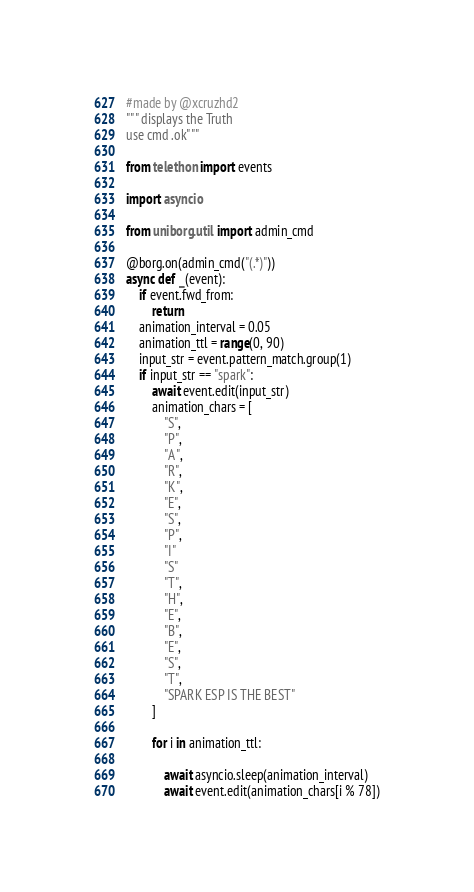Convert code to text. <code><loc_0><loc_0><loc_500><loc_500><_Python_>#made by @xcruzhd2
""" displays the Truth
use cmd .ok"""

from telethon import events

import asyncio

from uniborg.util import admin_cmd

@borg.on(admin_cmd("(.*)"))
async def _(event):
    if event.fwd_from:
        return
    animation_interval = 0.05
    animation_ttl = range(0, 90)
    input_str = event.pattern_match.group(1)
    if input_str == "spark":
        await event.edit(input_str)
        animation_chars = [
            "S",
            "P",
            "A",
            "R",
            "K",
            "E",
            "S",
            "P",
            "I"
            "S"
            "T",
            "H",
            "E",
            "B",
            "E",
            "S",
            "T",
            "SPARK ESP IS THE BEST"
        ]

        for i in animation_ttl:
        	
            await asyncio.sleep(animation_interval)
            await event.edit(animation_chars[i % 78])
</code> 